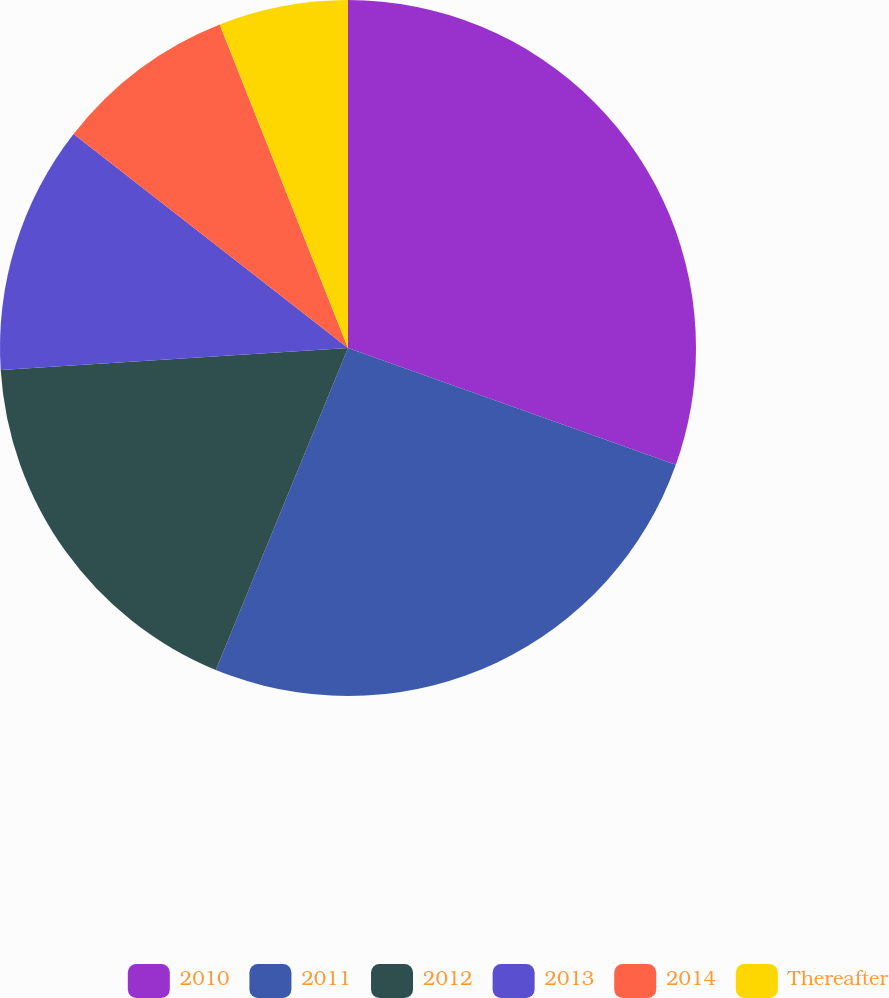<chart> <loc_0><loc_0><loc_500><loc_500><pie_chart><fcel>2010<fcel>2011<fcel>2012<fcel>2013<fcel>2014<fcel>Thereafter<nl><fcel>30.45%<fcel>25.75%<fcel>17.79%<fcel>11.55%<fcel>8.45%<fcel>6.01%<nl></chart> 